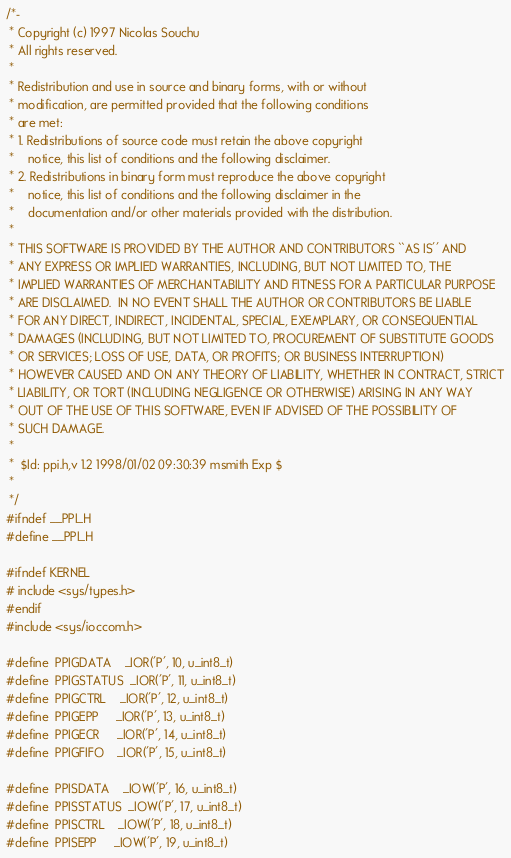Convert code to text. <code><loc_0><loc_0><loc_500><loc_500><_C_>/*-
 * Copyright (c) 1997 Nicolas Souchu
 * All rights reserved.
 *
 * Redistribution and use in source and binary forms, with or without
 * modification, are permitted provided that the following conditions
 * are met:
 * 1. Redistributions of source code must retain the above copyright
 *    notice, this list of conditions and the following disclaimer.
 * 2. Redistributions in binary form must reproduce the above copyright
 *    notice, this list of conditions and the following disclaimer in the
 *    documentation and/or other materials provided with the distribution.
 *
 * THIS SOFTWARE IS PROVIDED BY THE AUTHOR AND CONTRIBUTORS ``AS IS'' AND
 * ANY EXPRESS OR IMPLIED WARRANTIES, INCLUDING, BUT NOT LIMITED TO, THE
 * IMPLIED WARRANTIES OF MERCHANTABILITY AND FITNESS FOR A PARTICULAR PURPOSE
 * ARE DISCLAIMED.  IN NO EVENT SHALL THE AUTHOR OR CONTRIBUTORS BE LIABLE
 * FOR ANY DIRECT, INDIRECT, INCIDENTAL, SPECIAL, EXEMPLARY, OR CONSEQUENTIAL
 * DAMAGES (INCLUDING, BUT NOT LIMITED TO, PROCUREMENT OF SUBSTITUTE GOODS
 * OR SERVICES; LOSS OF USE, DATA, OR PROFITS; OR BUSINESS INTERRUPTION)
 * HOWEVER CAUSED AND ON ANY THEORY OF LIABILITY, WHETHER IN CONTRACT, STRICT
 * LIABILITY, OR TORT (INCLUDING NEGLIGENCE OR OTHERWISE) ARISING IN ANY WAY
 * OUT OF THE USE OF THIS SOFTWARE, EVEN IF ADVISED OF THE POSSIBILITY OF
 * SUCH DAMAGE.
 *
 *	$Id: ppi.h,v 1.2 1998/01/02 09:30:39 msmith Exp $
 *
 */
#ifndef __PPI_H
#define __PPI_H

#ifndef KERNEL
# include <sys/types.h>
#endif
#include <sys/ioccom.h>

#define	PPIGDATA	_IOR('P', 10, u_int8_t)
#define	PPIGSTATUS	_IOR('P', 11, u_int8_t)
#define	PPIGCTRL	_IOR('P', 12, u_int8_t)
#define	PPIGEPP		_IOR('P', 13, u_int8_t)
#define	PPIGECR		_IOR('P', 14, u_int8_t)
#define	PPIGFIFO	_IOR('P', 15, u_int8_t)

#define	PPISDATA	_IOW('P', 16, u_int8_t)
#define	PPISSTATUS	_IOW('P', 17, u_int8_t)
#define	PPISCTRL	_IOW('P', 18, u_int8_t)
#define	PPISEPP		_IOW('P', 19, u_int8_t)</code> 